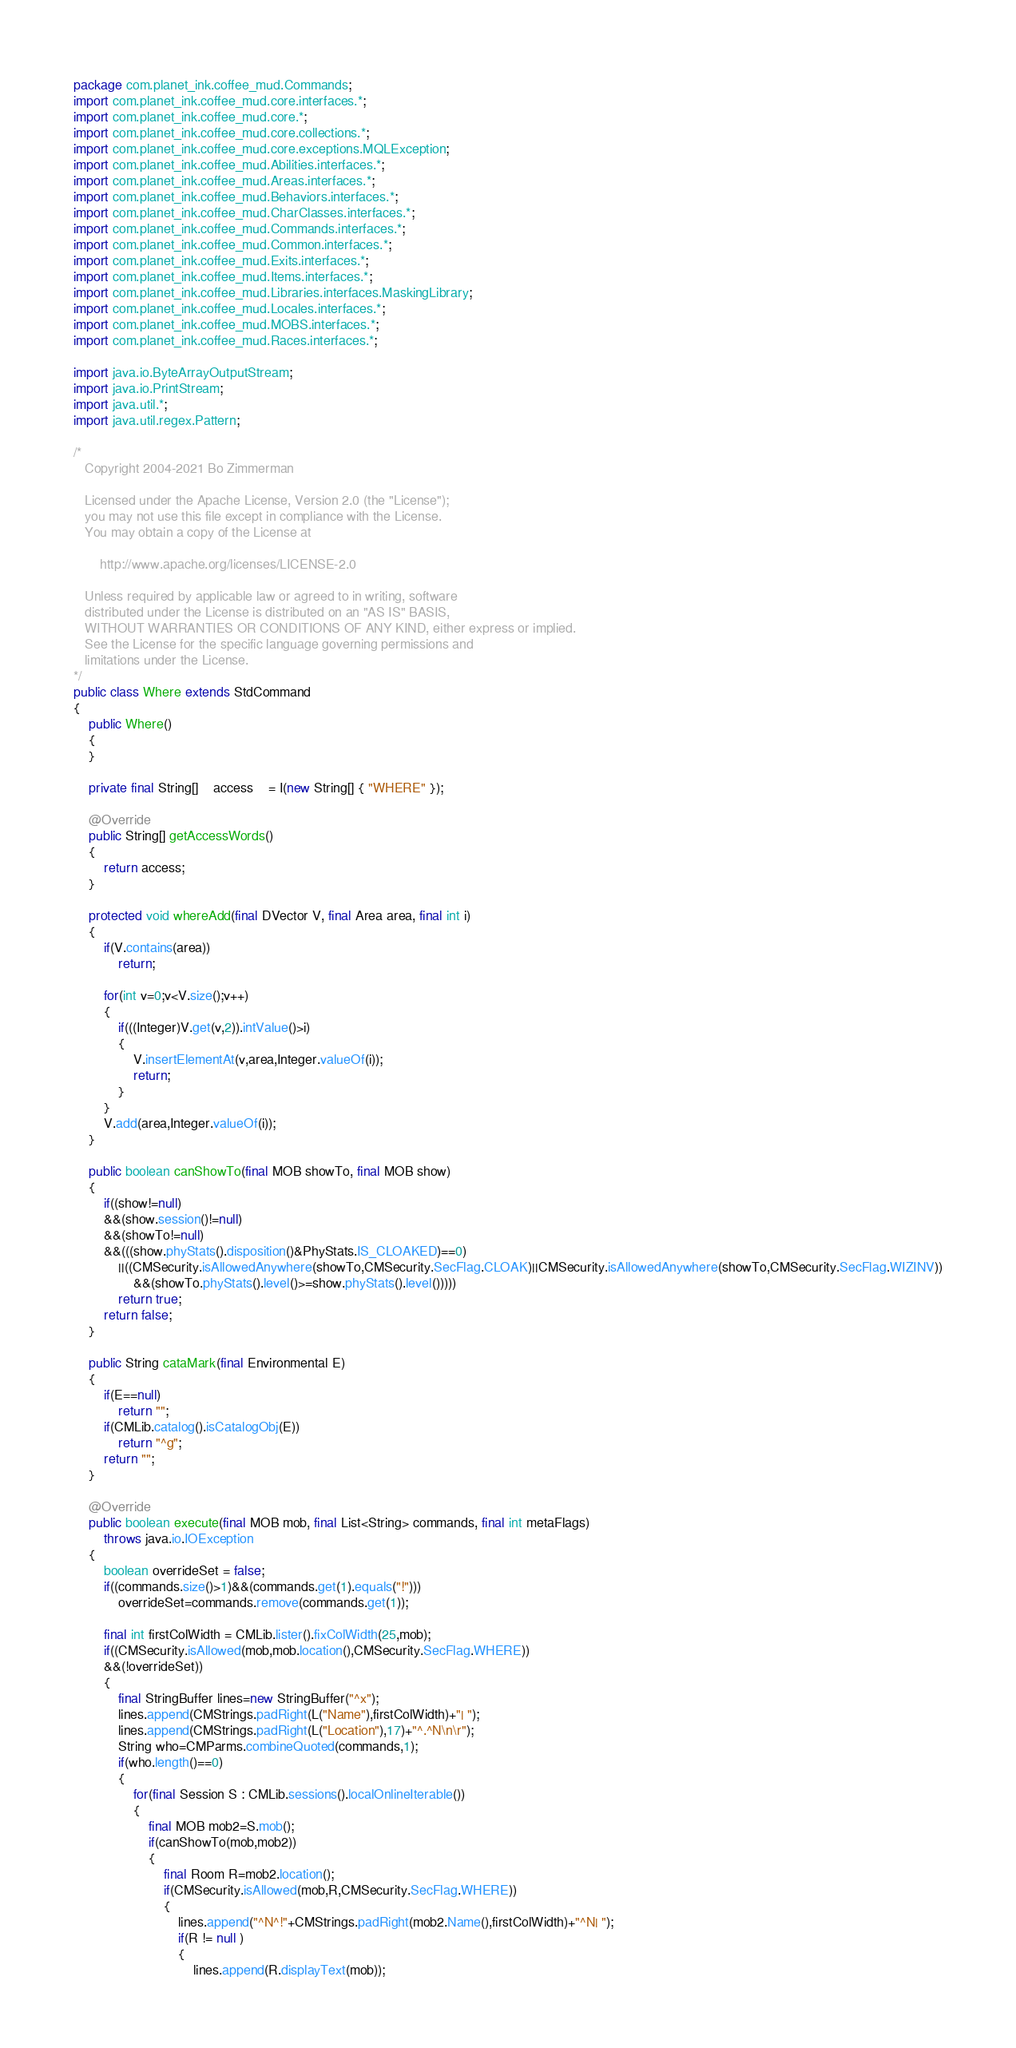Convert code to text. <code><loc_0><loc_0><loc_500><loc_500><_Java_>package com.planet_ink.coffee_mud.Commands;
import com.planet_ink.coffee_mud.core.interfaces.*;
import com.planet_ink.coffee_mud.core.*;
import com.planet_ink.coffee_mud.core.collections.*;
import com.planet_ink.coffee_mud.core.exceptions.MQLException;
import com.planet_ink.coffee_mud.Abilities.interfaces.*;
import com.planet_ink.coffee_mud.Areas.interfaces.*;
import com.planet_ink.coffee_mud.Behaviors.interfaces.*;
import com.planet_ink.coffee_mud.CharClasses.interfaces.*;
import com.planet_ink.coffee_mud.Commands.interfaces.*;
import com.planet_ink.coffee_mud.Common.interfaces.*;
import com.planet_ink.coffee_mud.Exits.interfaces.*;
import com.planet_ink.coffee_mud.Items.interfaces.*;
import com.planet_ink.coffee_mud.Libraries.interfaces.MaskingLibrary;
import com.planet_ink.coffee_mud.Locales.interfaces.*;
import com.planet_ink.coffee_mud.MOBS.interfaces.*;
import com.planet_ink.coffee_mud.Races.interfaces.*;

import java.io.ByteArrayOutputStream;
import java.io.PrintStream;
import java.util.*;
import java.util.regex.Pattern;

/*
   Copyright 2004-2021 Bo Zimmerman

   Licensed under the Apache License, Version 2.0 (the "License");
   you may not use this file except in compliance with the License.
   You may obtain a copy of the License at

	   http://www.apache.org/licenses/LICENSE-2.0

   Unless required by applicable law or agreed to in writing, software
   distributed under the License is distributed on an "AS IS" BASIS,
   WITHOUT WARRANTIES OR CONDITIONS OF ANY KIND, either express or implied.
   See the License for the specific language governing permissions and
   limitations under the License.
*/
public class Where extends StdCommand
{
	public Where()
	{
	}

	private final String[]	access	= I(new String[] { "WHERE" });

	@Override
	public String[] getAccessWords()
	{
		return access;
	}

	protected void whereAdd(final DVector V, final Area area, final int i)
	{
		if(V.contains(area))
			return;

		for(int v=0;v<V.size();v++)
		{
			if(((Integer)V.get(v,2)).intValue()>i)
			{
				V.insertElementAt(v,area,Integer.valueOf(i));
				return;
			}
		}
		V.add(area,Integer.valueOf(i));
	}

	public boolean canShowTo(final MOB showTo, final MOB show)
	{
		if((show!=null)
		&&(show.session()!=null)
		&&(showTo!=null)
		&&(((show.phyStats().disposition()&PhyStats.IS_CLOAKED)==0)
			||((CMSecurity.isAllowedAnywhere(showTo,CMSecurity.SecFlag.CLOAK)||CMSecurity.isAllowedAnywhere(showTo,CMSecurity.SecFlag.WIZINV))
				&&(showTo.phyStats().level()>=show.phyStats().level()))))
			return true;
		return false;
	}

	public String cataMark(final Environmental E)
	{
		if(E==null)
			return "";
		if(CMLib.catalog().isCatalogObj(E))
			return "^g";
		return "";
	}

	@Override
	public boolean execute(final MOB mob, final List<String> commands, final int metaFlags)
		throws java.io.IOException
	{
		boolean overrideSet = false;
		if((commands.size()>1)&&(commands.get(1).equals("!")))
			overrideSet=commands.remove(commands.get(1));

		final int firstColWidth = CMLib.lister().fixColWidth(25,mob);
		if((CMSecurity.isAllowed(mob,mob.location(),CMSecurity.SecFlag.WHERE))
		&&(!overrideSet))
		{
			final StringBuffer lines=new StringBuffer("^x");
			lines.append(CMStrings.padRight(L("Name"),firstColWidth)+"| ");
			lines.append(CMStrings.padRight(L("Location"),17)+"^.^N\n\r");
			String who=CMParms.combineQuoted(commands,1);
			if(who.length()==0)
			{
				for(final Session S : CMLib.sessions().localOnlineIterable())
				{
					final MOB mob2=S.mob();
					if(canShowTo(mob,mob2))
					{
						final Room R=mob2.location();
						if(CMSecurity.isAllowed(mob,R,CMSecurity.SecFlag.WHERE))
						{
							lines.append("^N^!"+CMStrings.padRight(mob2.Name(),firstColWidth)+"^N| ");
							if(R != null )
							{
								lines.append(R.displayText(mob));</code> 